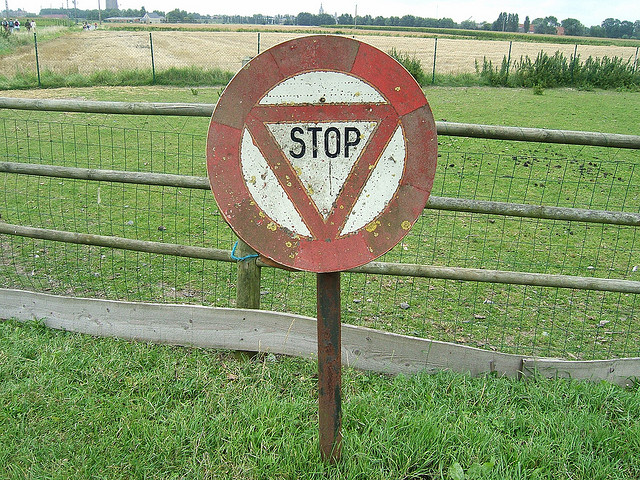<image>What kind of wire is being used for fencing? I am not sure what kind of wire is being used for fencing. It can be wood, barbed, chicken wire, mesh or square wire. What kind of wire is being used for fencing? I don't know what kind of wire is being used for fencing. It could be wood, barbed wire, chicken wire, mesh, or square wire. 